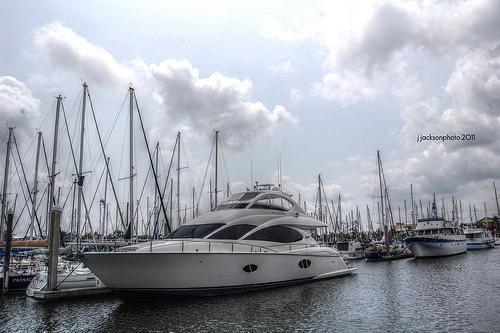Question: what kind of vehicles are shown in the photo?
Choices:
A. Cars.
B. Boats.
C. Trains.
D. Bicycles.
Answer with the letter. Answer: B Question: how many windows are showing on the boat in the foreground?
Choices:
A. Six.
B. One.
C. Two.
D. Five.
Answer with the letter. Answer: D Question: what color is the sky?
Choices:
A. Red and orange.
B. Blue and white.
C. Yellow and green.
D. Purple and red.
Answer with the letter. Answer: B 